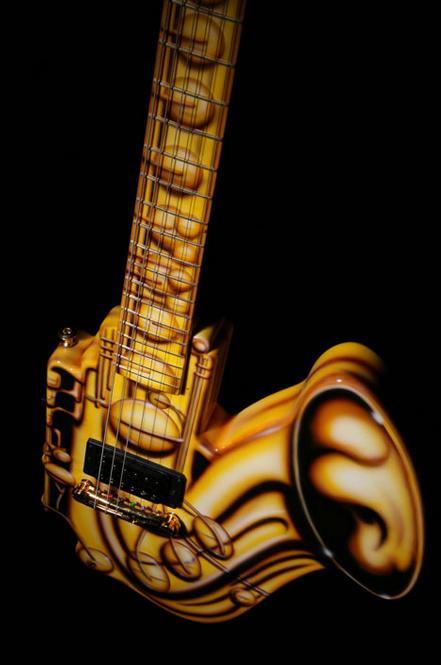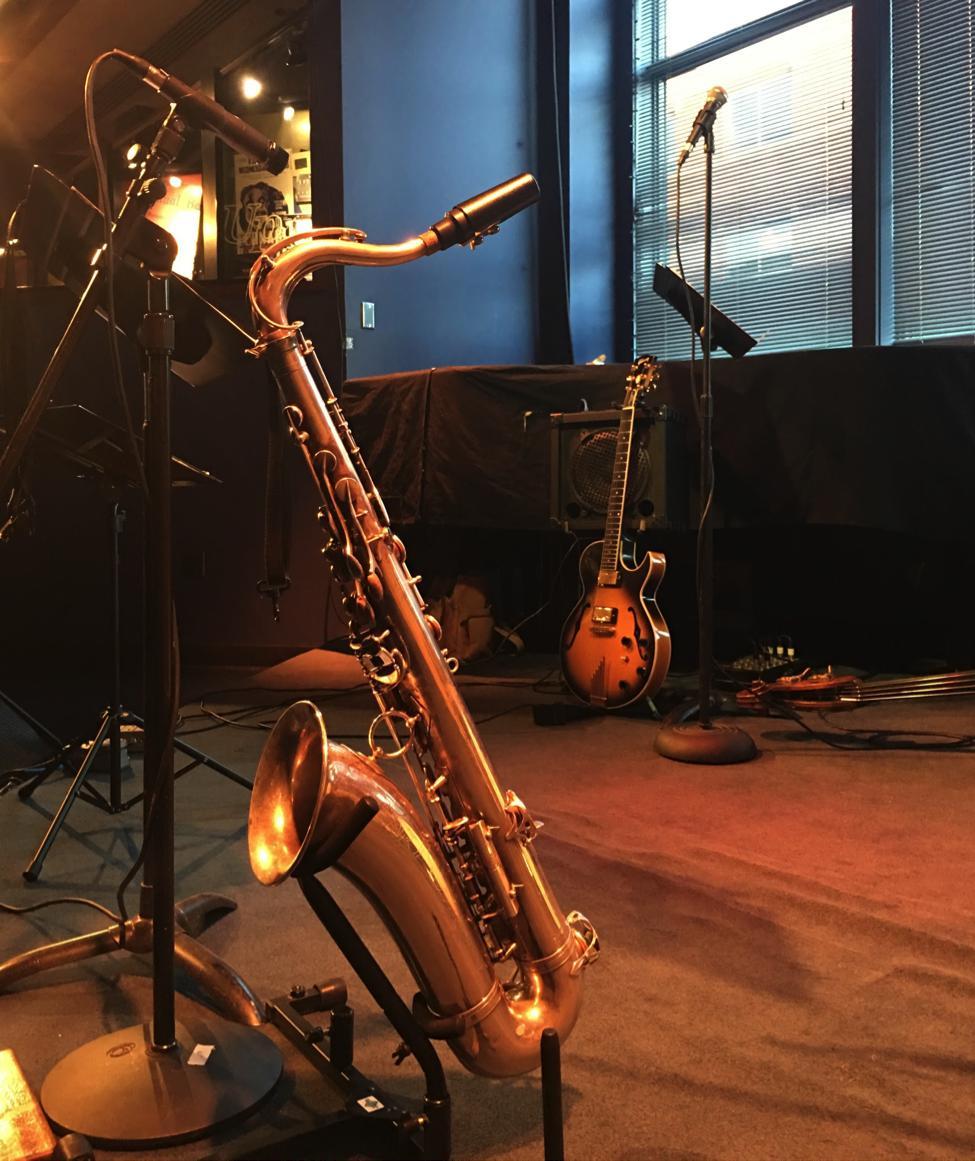The first image is the image on the left, the second image is the image on the right. Evaluate the accuracy of this statement regarding the images: "The left and right image contains the same number of saxophones and guitars.". Is it true? Answer yes or no. No. The first image is the image on the left, the second image is the image on the right. Analyze the images presented: Is the assertion "There are two saxophones and one guitar" valid? Answer yes or no. Yes. 